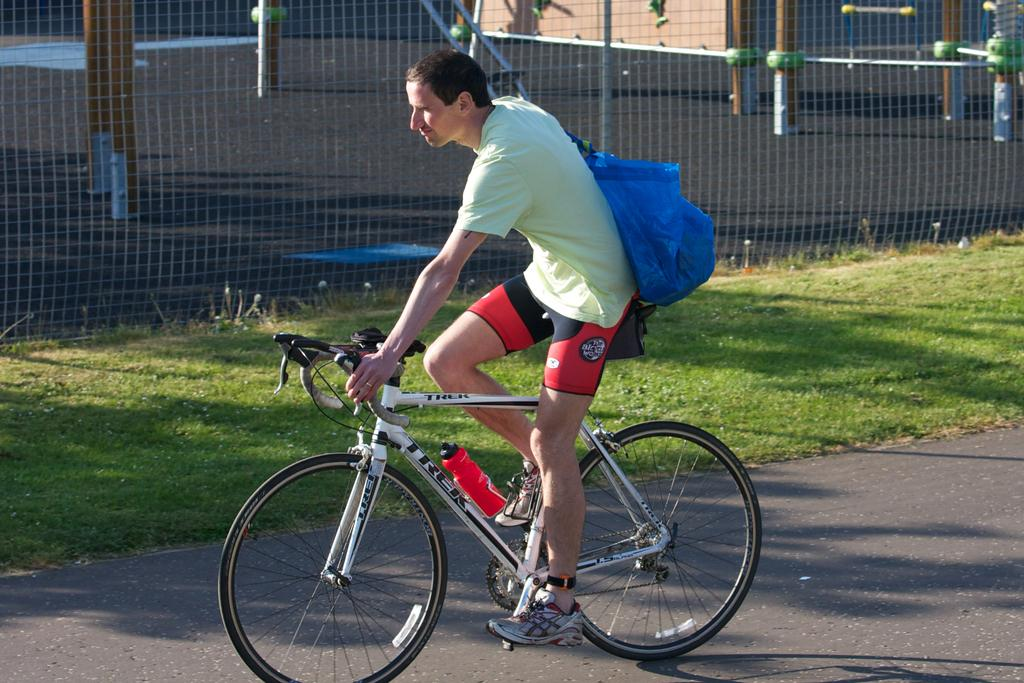What is the main subject of the image? There is a person riding a bicycle in the image. What is the person wearing in the image? The person is wearing a blue color bag. What can be seen in the background of the image? There is a net fencing, poles, and grass visible in the background of the image. What type of engine is powering the bicycle in the image? There is no engine present in the image, as bicycles are typically powered by the rider's pedaling. What news event is the person on the bicycle reporting on? There is no indication in the image that the person is reporting on any news event. 